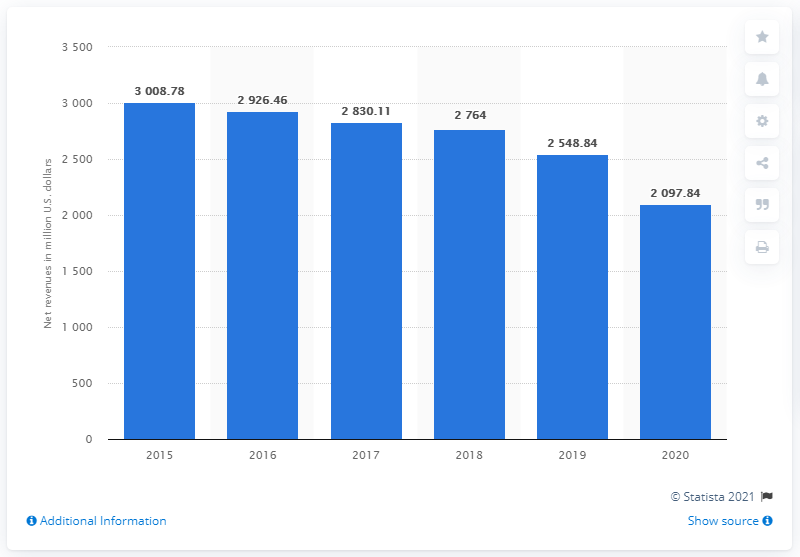Specify some key components in this picture. Kontoor Brands made a net income of approximately 2,097.84 million dollars in the United States in the year 2020. 